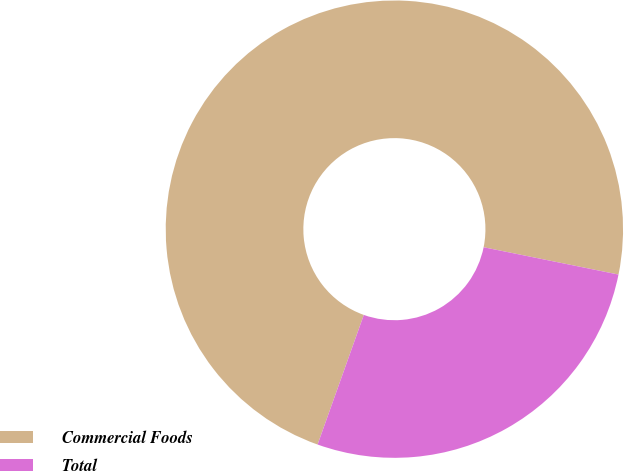Convert chart. <chart><loc_0><loc_0><loc_500><loc_500><pie_chart><fcel>Commercial Foods<fcel>Total<nl><fcel>72.73%<fcel>27.27%<nl></chart> 